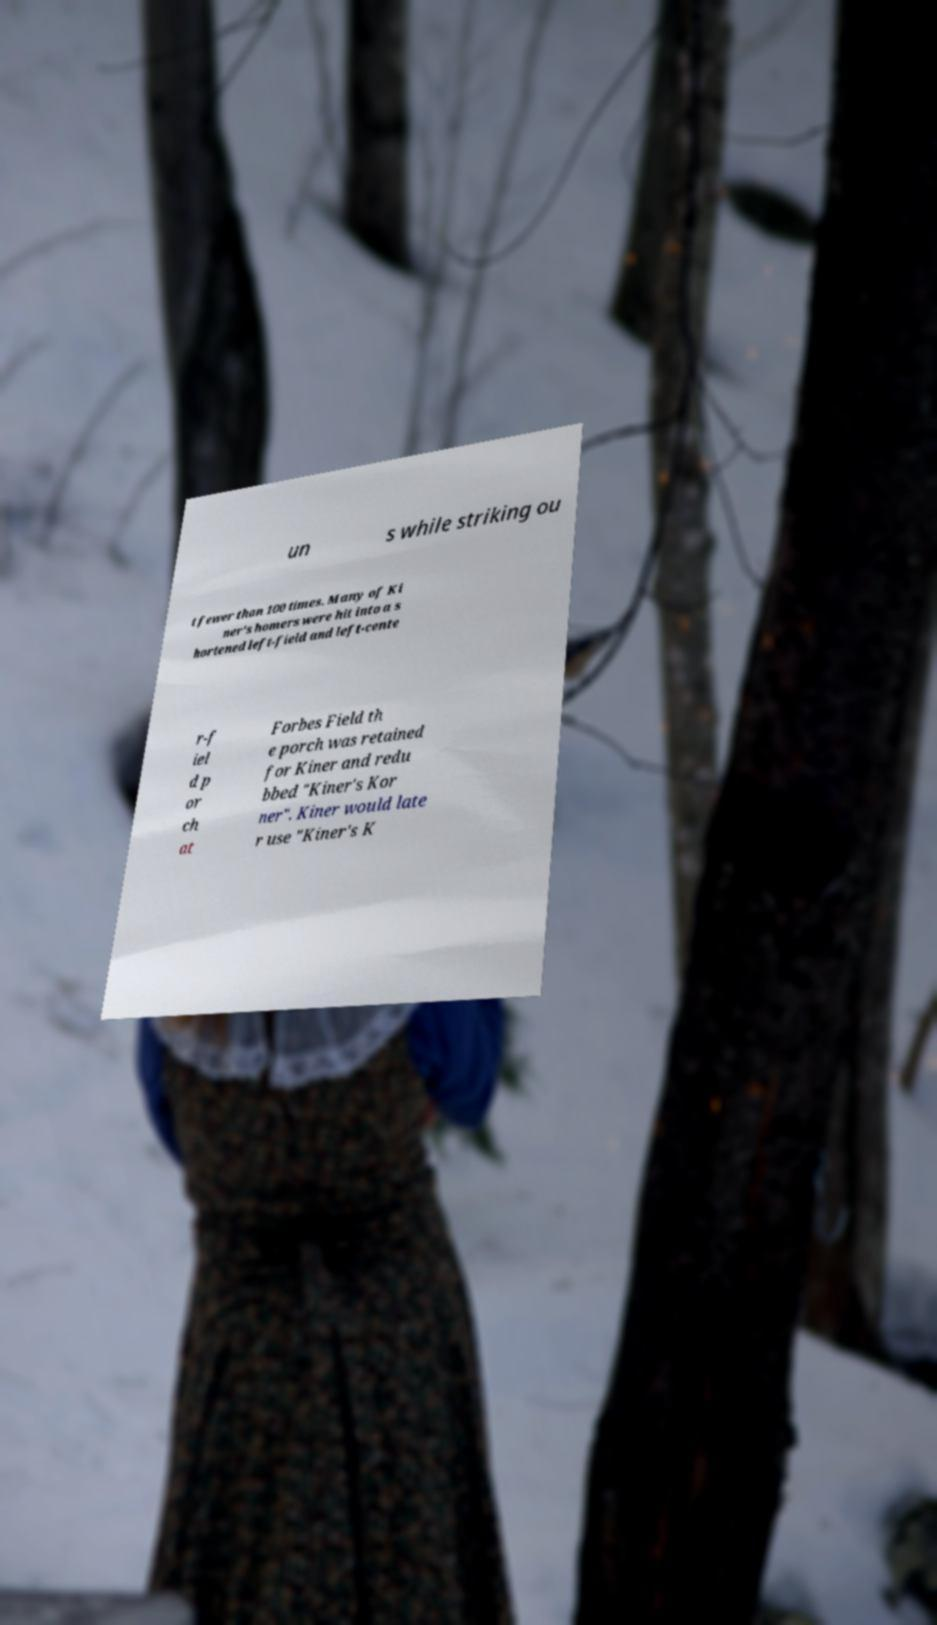Can you accurately transcribe the text from the provided image for me? un s while striking ou t fewer than 100 times. Many of Ki ner's homers were hit into a s hortened left-field and left-cente r-f iel d p or ch at Forbes Field th e porch was retained for Kiner and redu bbed "Kiner's Kor ner". Kiner would late r use "Kiner's K 